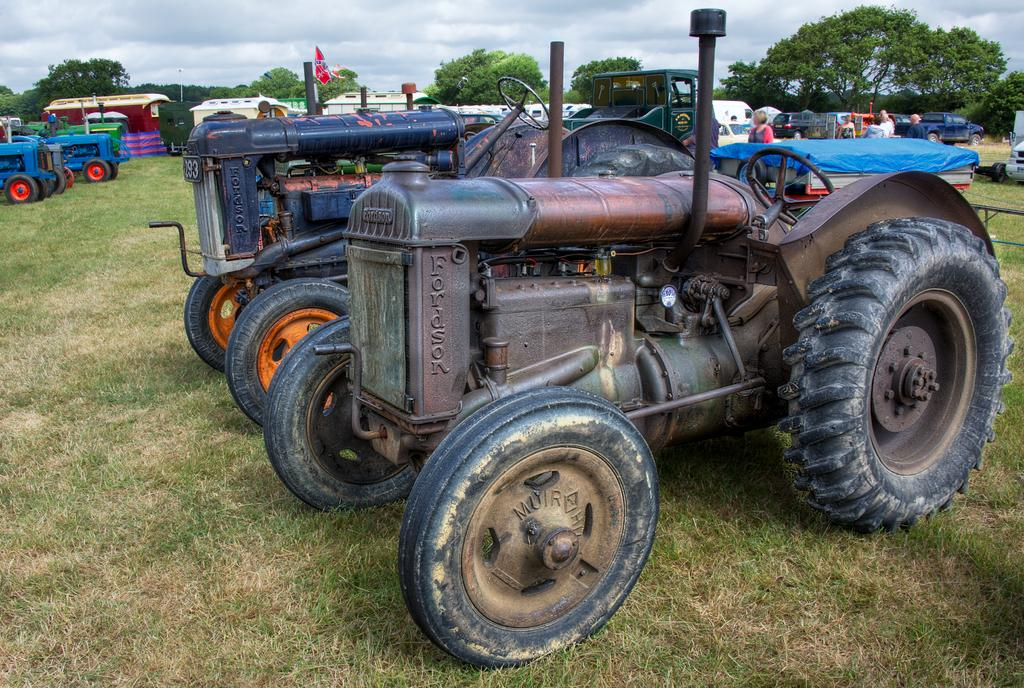What type of vehicles can be seen on the right side of the image? There are tractors parked on the grass on the right side of the image. What else can be seen in the background of the image? There are vehicles, persons, and trees visible in the background of the image. What is the condition of the sky in the image? There are clouds visible in the sky. Where is the toothbrush located in the image? There is no toothbrush present in the image. What type of coach can be seen interacting with the persons in the image? There is no coach present in the image; only tractors, vehicles, persons, trees, and clouds are visible. 